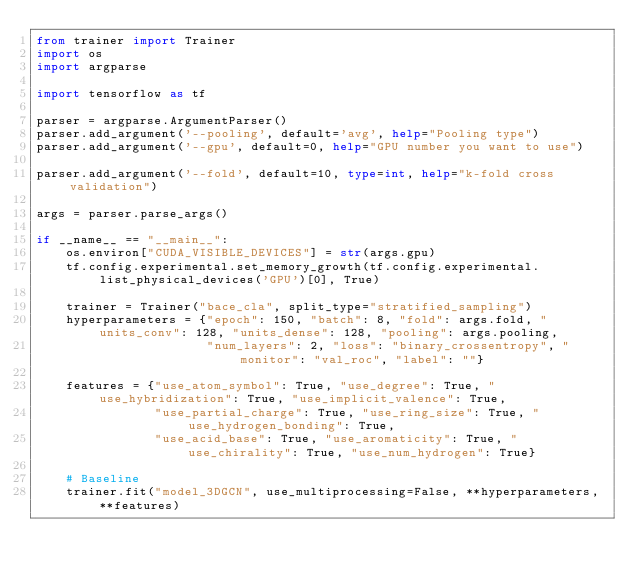Convert code to text. <code><loc_0><loc_0><loc_500><loc_500><_Python_>from trainer import Trainer
import os
import argparse

import tensorflow as tf

parser = argparse.ArgumentParser()
parser.add_argument('--pooling', default='avg', help="Pooling type")
parser.add_argument('--gpu', default=0, help="GPU number you want to use")

parser.add_argument('--fold', default=10, type=int, help="k-fold cross validation")

args = parser.parse_args()

if __name__ == "__main__":
    os.environ["CUDA_VISIBLE_DEVICES"] = str(args.gpu)
    tf.config.experimental.set_memory_growth(tf.config.experimental.list_physical_devices('GPU')[0], True)

    trainer = Trainer("bace_cla", split_type="stratified_sampling")
    hyperparameters = {"epoch": 150, "batch": 8, "fold": args.fold, "units_conv": 128, "units_dense": 128, "pooling": args.pooling,
                       "num_layers": 2, "loss": "binary_crossentropy", "monitor": "val_roc", "label": ""}

    features = {"use_atom_symbol": True, "use_degree": True, "use_hybridization": True, "use_implicit_valence": True,
                "use_partial_charge": True, "use_ring_size": True, "use_hydrogen_bonding": True,
                "use_acid_base": True, "use_aromaticity": True, "use_chirality": True, "use_num_hydrogen": True}

    # Baseline
    trainer.fit("model_3DGCN", use_multiprocessing=False, **hyperparameters, **features)

</code> 